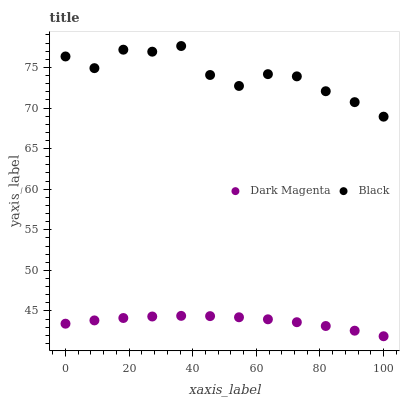Does Dark Magenta have the minimum area under the curve?
Answer yes or no. Yes. Does Black have the maximum area under the curve?
Answer yes or no. Yes. Does Dark Magenta have the maximum area under the curve?
Answer yes or no. No. Is Dark Magenta the smoothest?
Answer yes or no. Yes. Is Black the roughest?
Answer yes or no. Yes. Is Dark Magenta the roughest?
Answer yes or no. No. Does Dark Magenta have the lowest value?
Answer yes or no. Yes. Does Black have the highest value?
Answer yes or no. Yes. Does Dark Magenta have the highest value?
Answer yes or no. No. Is Dark Magenta less than Black?
Answer yes or no. Yes. Is Black greater than Dark Magenta?
Answer yes or no. Yes. Does Dark Magenta intersect Black?
Answer yes or no. No. 